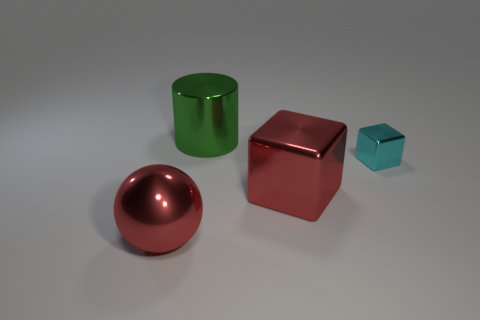Is the large metallic sphere the same color as the large shiny block?
Provide a succinct answer. Yes. What number of things are large yellow shiny balls or red metallic things right of the red metallic sphere?
Keep it short and to the point. 1. Is the size of the object behind the cyan metallic thing the same as the cyan object?
Your response must be concise. No. How many other things are there of the same shape as the big green object?
Make the answer very short. 0. What number of red objects are big shiny cubes or big metallic spheres?
Provide a succinct answer. 2. Does the block that is left of the cyan metallic block have the same color as the big metal sphere?
Provide a succinct answer. Yes. What is the shape of the cyan thing that is made of the same material as the big cube?
Offer a terse response. Cube. What is the color of the metallic thing that is both on the left side of the large block and on the right side of the large red ball?
Your response must be concise. Green. There is a shiny thing that is to the right of the red shiny object that is right of the green cylinder; how big is it?
Give a very brief answer. Small. Are there any big metallic objects of the same color as the big cube?
Give a very brief answer. Yes. 